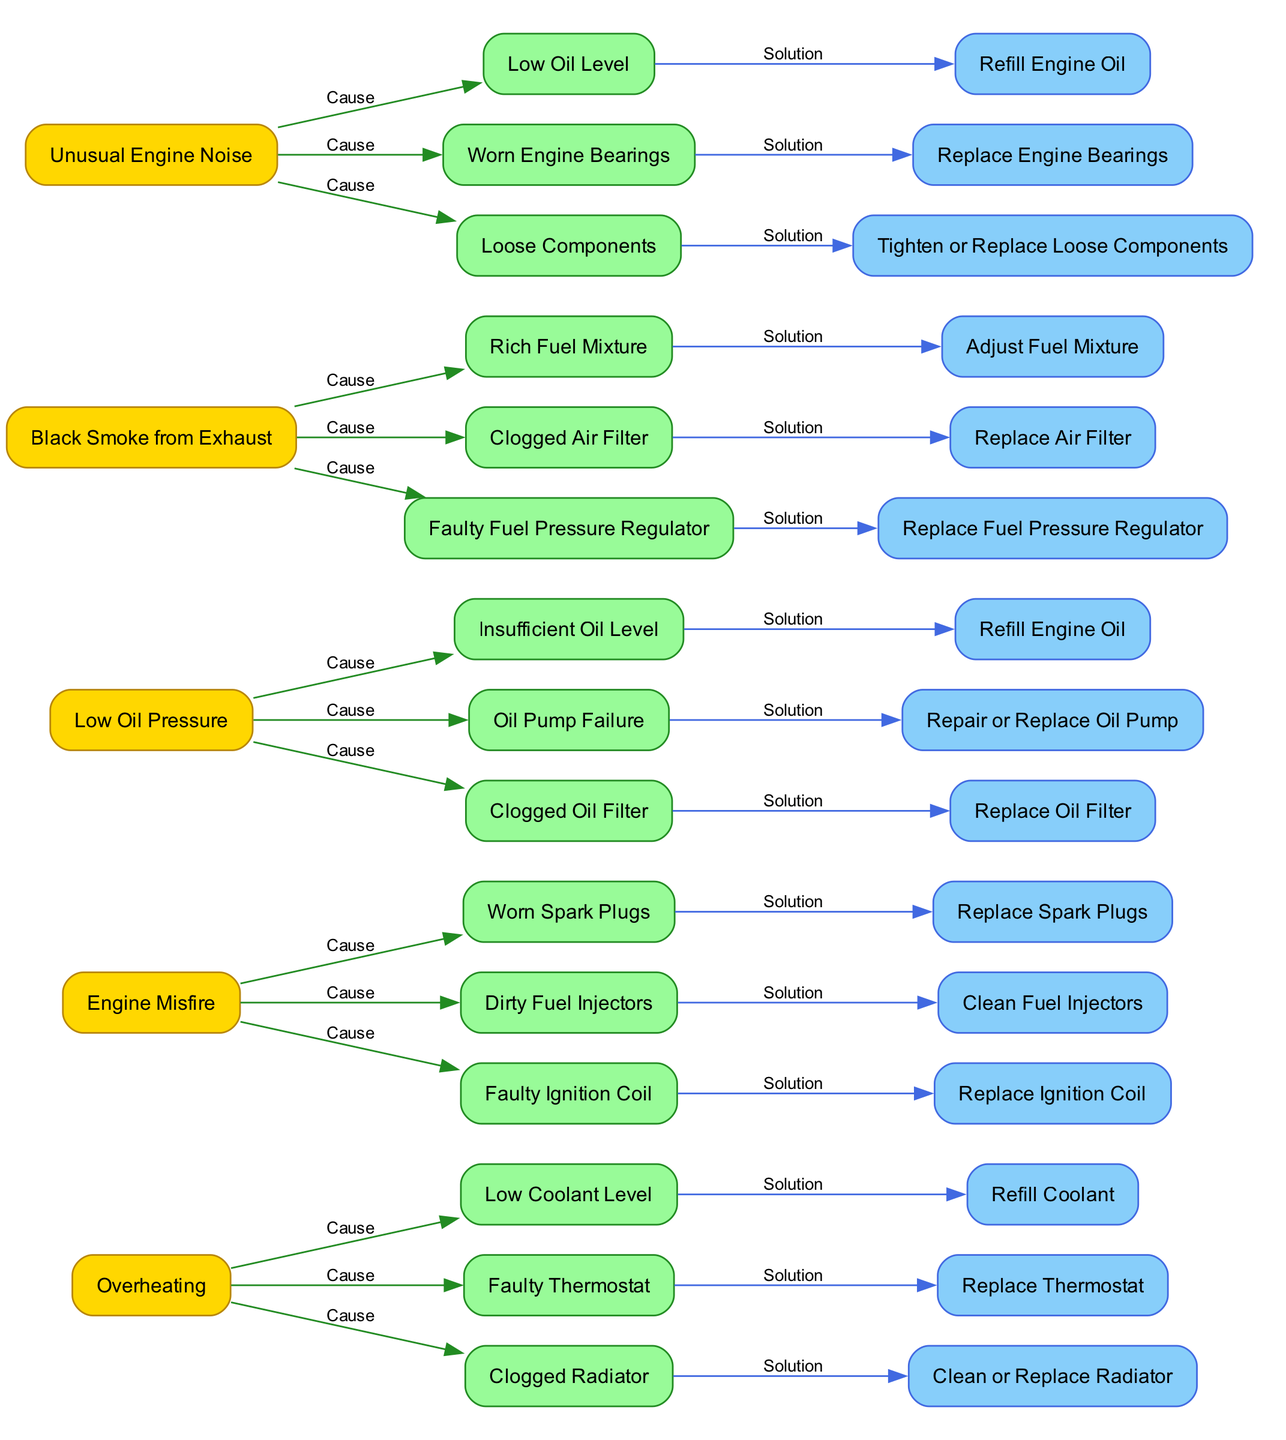What symptom is associated with "Low Coolant Level"? Navigate through the diagram to find the node for "Low Coolant Level" and identify its parent node. The parent node is "Overheating," indicating that overheating is the symptom associated with low coolant level.
Answer: Overheating How many causes are listed for "Engine Misfire"? Count the nodes connected to the "Engine Misfire" symptom node, specifically looking for the "Cause" edges. There are three nodes linked, indicating three causes for engine misfire.
Answer: 3 What solution corresponds to "Clogged Radiator"? Find the node "Clogged Radiator" and check its adjacent edge to identify the connected solution node. The solution node linked is "Clean or Replace Radiator," indicating this is the solution for a clogged radiator.
Answer: Clean or Replace Radiator What is one cause of "Low Oil Pressure"? Identify the nodes branching from "Low Oil Pressure" and note the first cause listed. The first cause is "Insufficient Oil Level," which is one of the causes associated with low oil pressure.
Answer: Insufficient Oil Level If the engine is making an "Unusual Engine Noise," what should be replaced? Look at the symptom "Unusual Engine Noise" and review the connected solutions. One of the solutions is "Replace Engine Bearings," which directly addresses the issue of unusual engine noise.
Answer: Replace Engine Bearings What are the two symptoms that have "Clogged" listed as a cause? Scan through the diagram for nodes that contain the term "Clogged" in their cause relationships. The symptoms that have this cause are "Low Oil Pressure" and "Black Smoke from Exhaust."
Answer: Low Oil Pressure, Black Smoke from Exhaust Which symptom has the highest number of solutions? Count the number of solutions provided for each symptom. "Engine Misfire" has three solutions, which is equal to others, but compare all to confirm if any have more. For this context, it's evident that several share the same count, but check for clear distinctions as needed.
Answer: All share 3 solutions What cause is shared between "Black Smoke from Exhaust" and "Engine Misfire"? Look for common nodes under both symptoms that identify as causes. Both symptoms share the cause related to the fuel injectors.
Answer: Dirty Fuel Injectors 